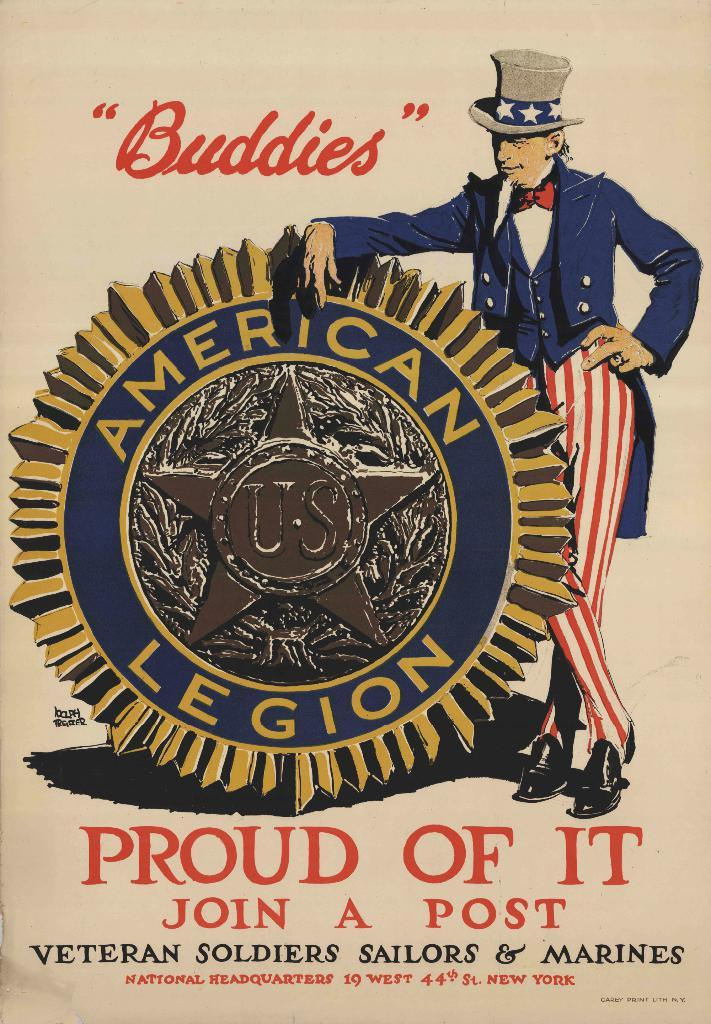<image>
Write a terse but informative summary of the picture. Uncle Sam standing next to an American Legion logo. 